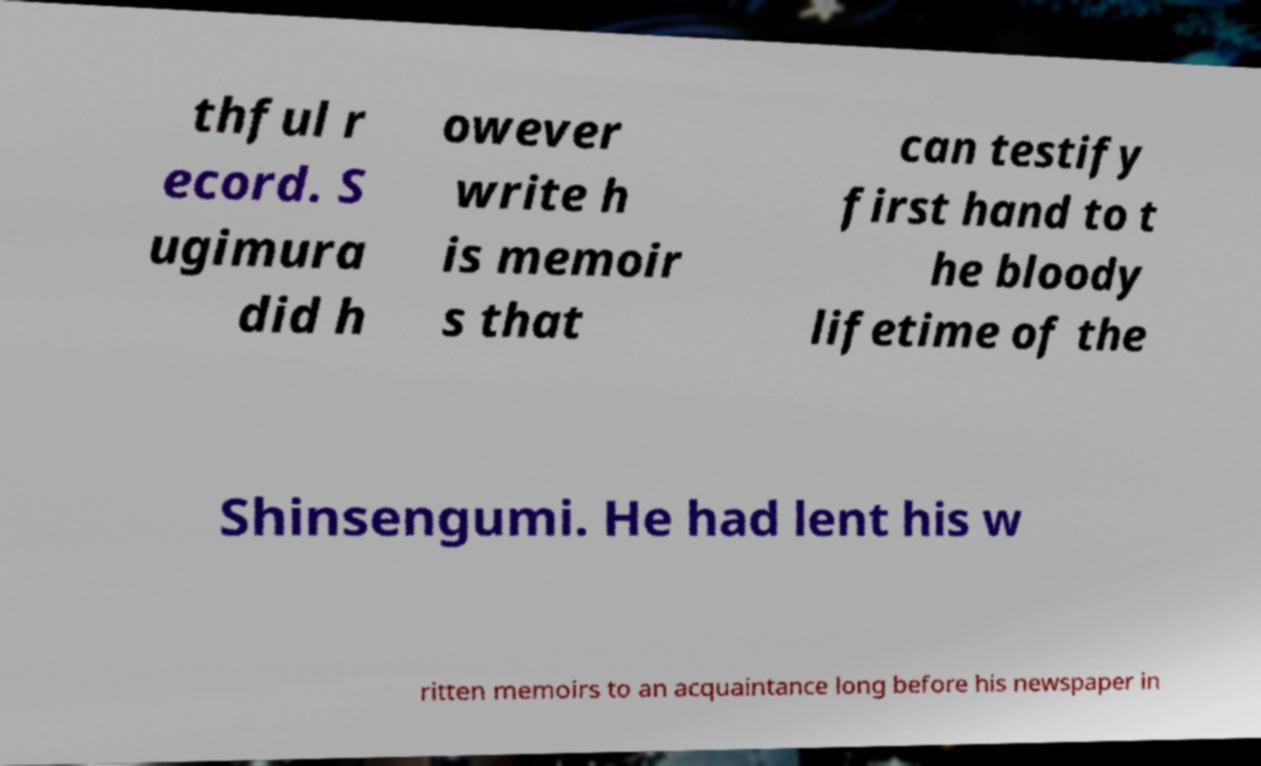I need the written content from this picture converted into text. Can you do that? thful r ecord. S ugimura did h owever write h is memoir s that can testify first hand to t he bloody lifetime of the Shinsengumi. He had lent his w ritten memoirs to an acquaintance long before his newspaper in 